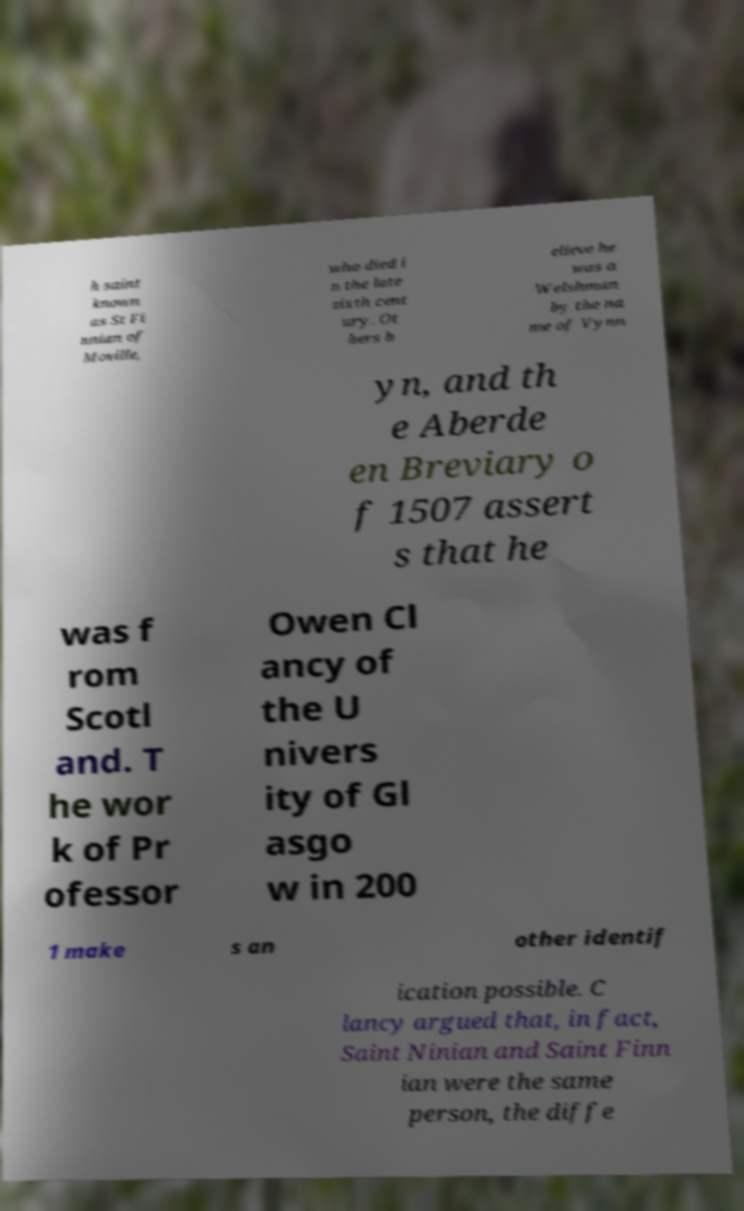Could you assist in decoding the text presented in this image and type it out clearly? h saint known as St Fi nnian of Moville, who died i n the late sixth cent ury. Ot hers b elieve he was a Welshman by the na me of Vynn yn, and th e Aberde en Breviary o f 1507 assert s that he was f rom Scotl and. T he wor k of Pr ofessor Owen Cl ancy of the U nivers ity of Gl asgo w in 200 1 make s an other identif ication possible. C lancy argued that, in fact, Saint Ninian and Saint Finn ian were the same person, the diffe 